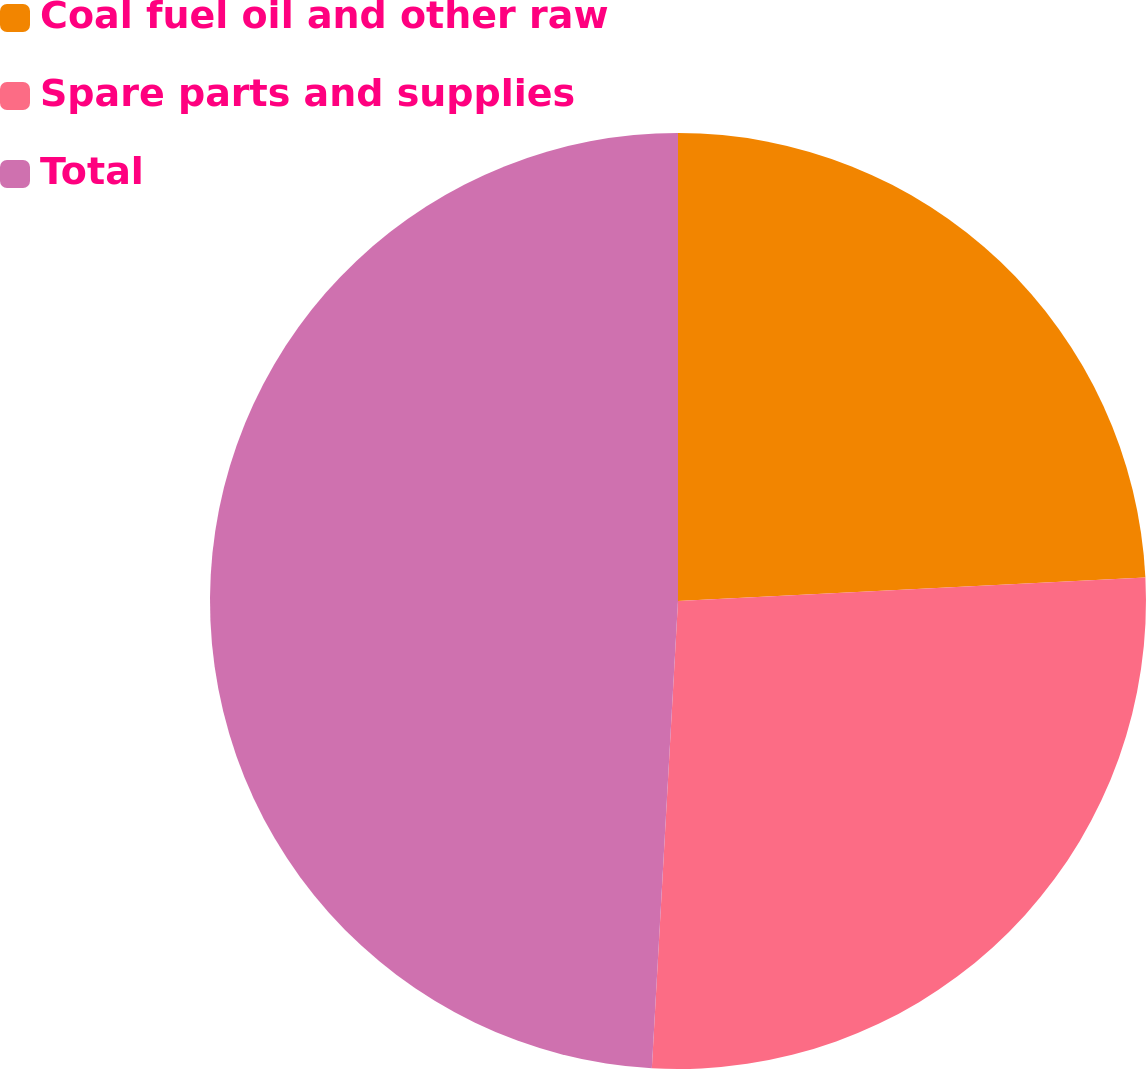<chart> <loc_0><loc_0><loc_500><loc_500><pie_chart><fcel>Coal fuel oil and other raw<fcel>Spare parts and supplies<fcel>Total<nl><fcel>24.2%<fcel>26.69%<fcel>49.11%<nl></chart> 